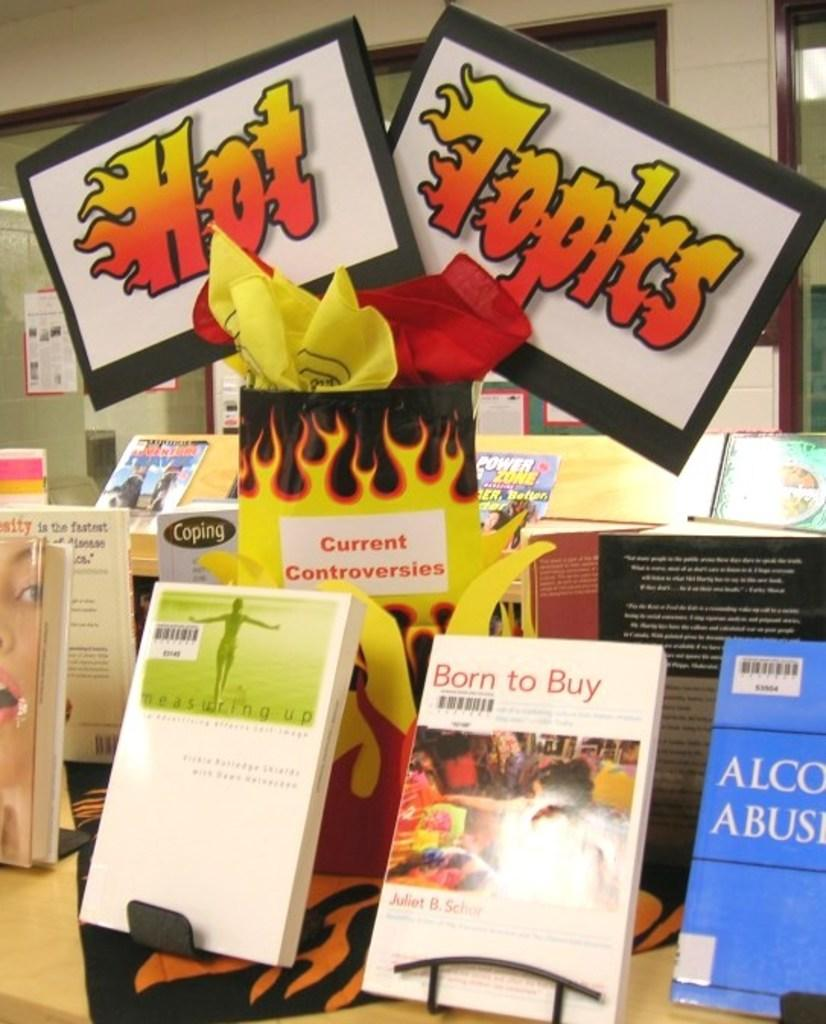<image>
Summarize the visual content of the image. A sign displays the words hot topics above books. 